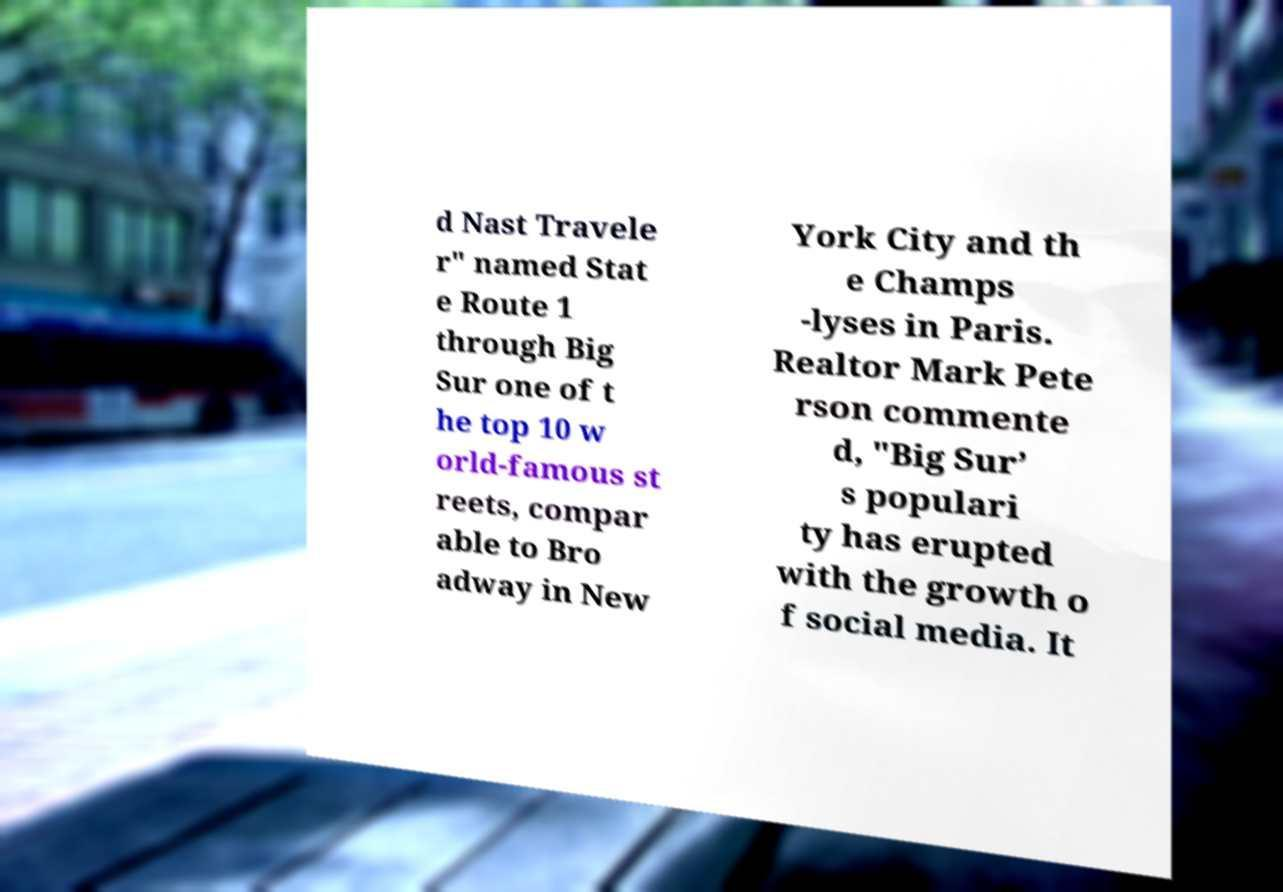Please identify and transcribe the text found in this image. d Nast Travele r" named Stat e Route 1 through Big Sur one of t he top 10 w orld-famous st reets, compar able to Bro adway in New York City and th e Champs -lyses in Paris. Realtor Mark Pete rson commente d, "Big Sur’ s populari ty has erupted with the growth o f social media. It 